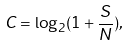Convert formula to latex. <formula><loc_0><loc_0><loc_500><loc_500>C = \log _ { 2 } ( 1 + \frac { S } { N } ) ,</formula> 